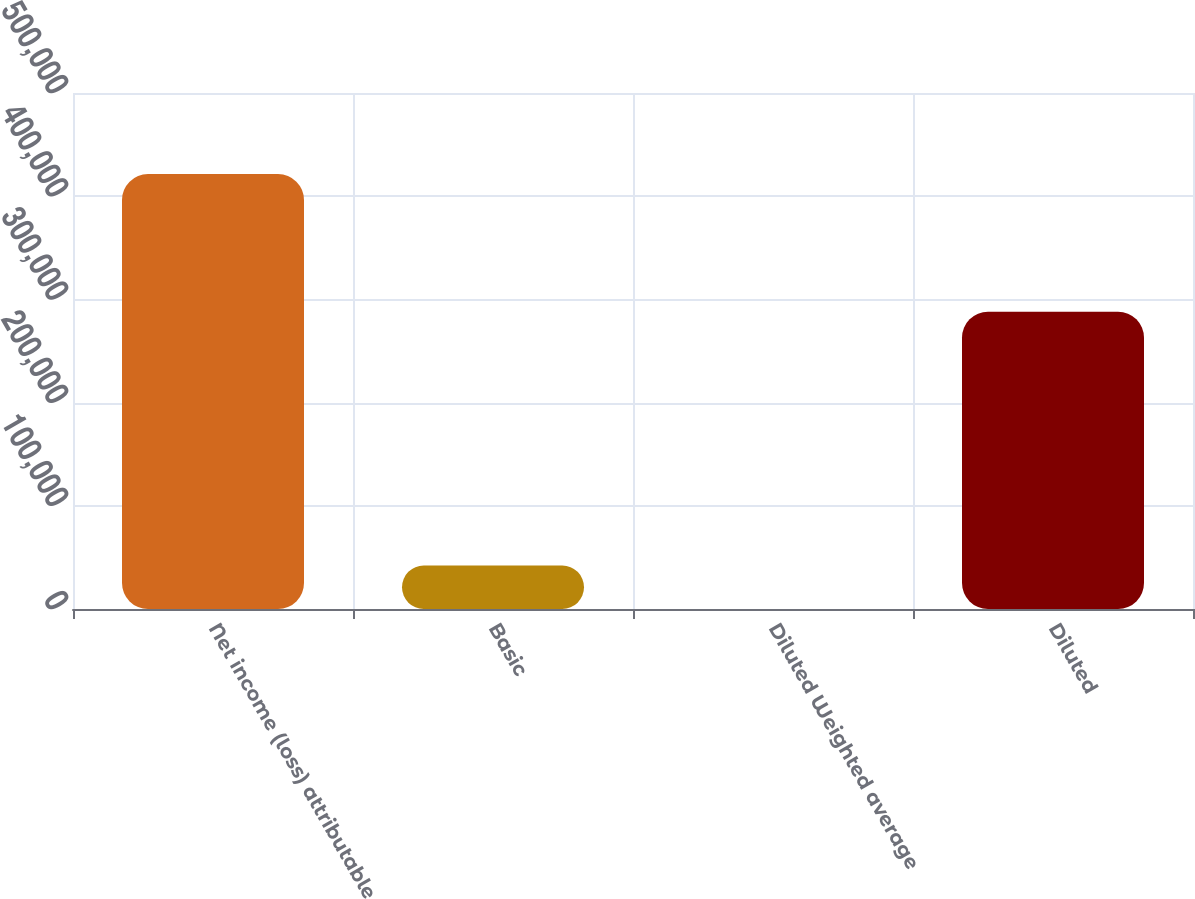Convert chart. <chart><loc_0><loc_0><loc_500><loc_500><bar_chart><fcel>Net income (loss) attributable<fcel>Basic<fcel>Diluted Weighted average<fcel>Diluted<nl><fcel>421500<fcel>42151.3<fcel>1.46<fcel>288028<nl></chart> 